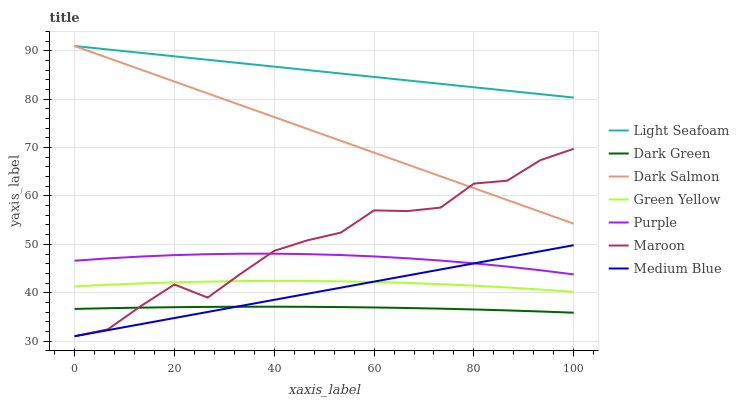Does Dark Green have the minimum area under the curve?
Answer yes or no. Yes. Does Light Seafoam have the maximum area under the curve?
Answer yes or no. Yes. Does Purple have the minimum area under the curve?
Answer yes or no. No. Does Purple have the maximum area under the curve?
Answer yes or no. No. Is Medium Blue the smoothest?
Answer yes or no. Yes. Is Maroon the roughest?
Answer yes or no. Yes. Is Purple the smoothest?
Answer yes or no. No. Is Purple the roughest?
Answer yes or no. No. Does Purple have the lowest value?
Answer yes or no. No. Does Dark Salmon have the highest value?
Answer yes or no. Yes. Does Purple have the highest value?
Answer yes or no. No. Is Medium Blue less than Light Seafoam?
Answer yes or no. Yes. Is Light Seafoam greater than Dark Green?
Answer yes or no. Yes. Does Medium Blue intersect Maroon?
Answer yes or no. Yes. Is Medium Blue less than Maroon?
Answer yes or no. No. Is Medium Blue greater than Maroon?
Answer yes or no. No. Does Medium Blue intersect Light Seafoam?
Answer yes or no. No. 